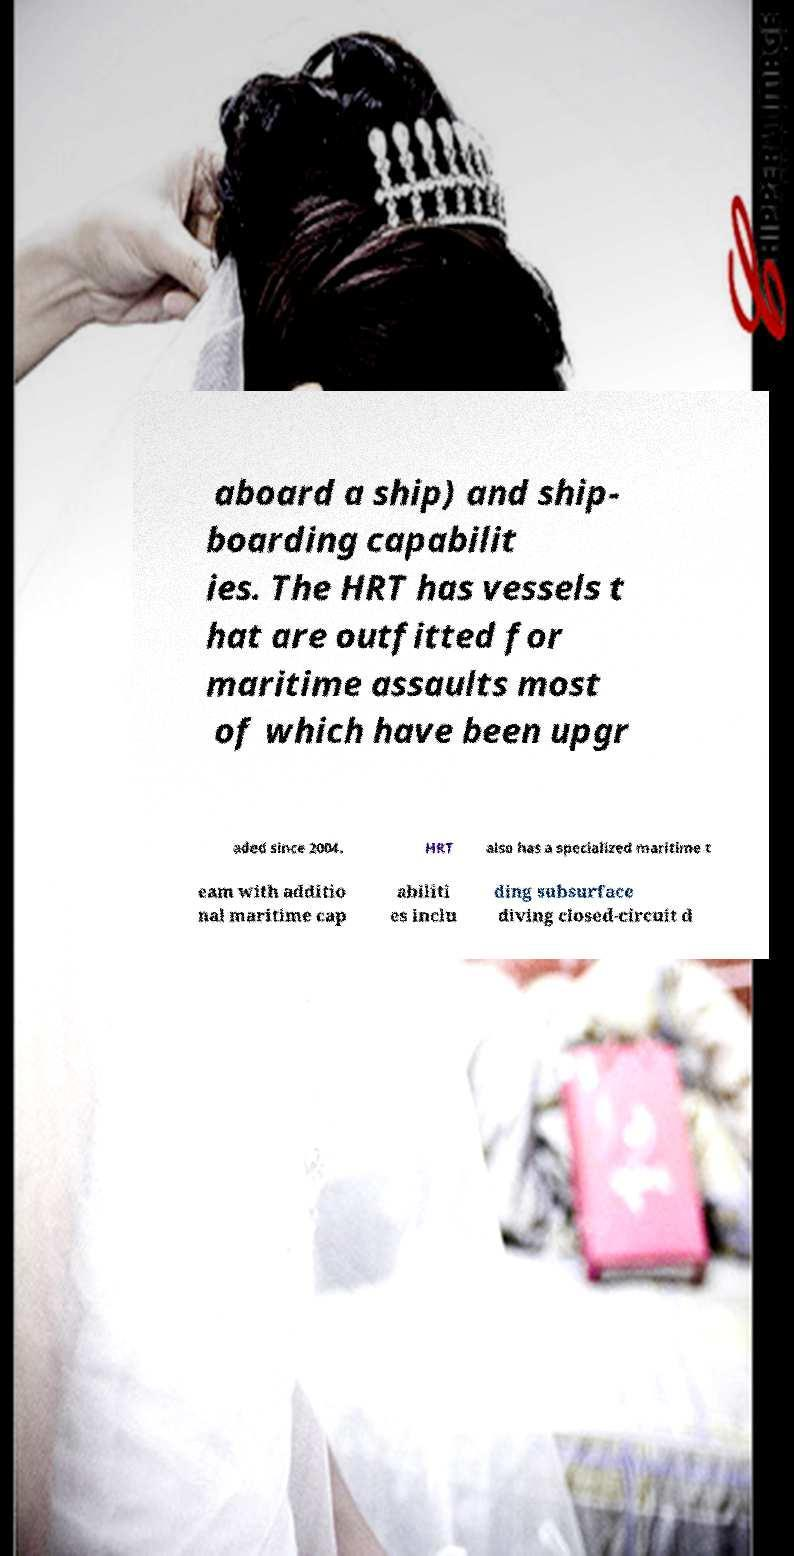Could you extract and type out the text from this image? aboard a ship) and ship- boarding capabilit ies. The HRT has vessels t hat are outfitted for maritime assaults most of which have been upgr aded since 2004. HRT also has a specialized maritime t eam with additio nal maritime cap abiliti es inclu ding subsurface diving closed-circuit d 